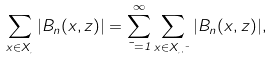Convert formula to latex. <formula><loc_0><loc_0><loc_500><loc_500>\sum _ { x \in X _ { \xi } } | B _ { n } ( x , z ) | = \sum _ { \mu = 1 } ^ { \infty } \sum _ { x \in X _ { \xi , \mu } } | B _ { n } ( x , z ) | ,</formula> 